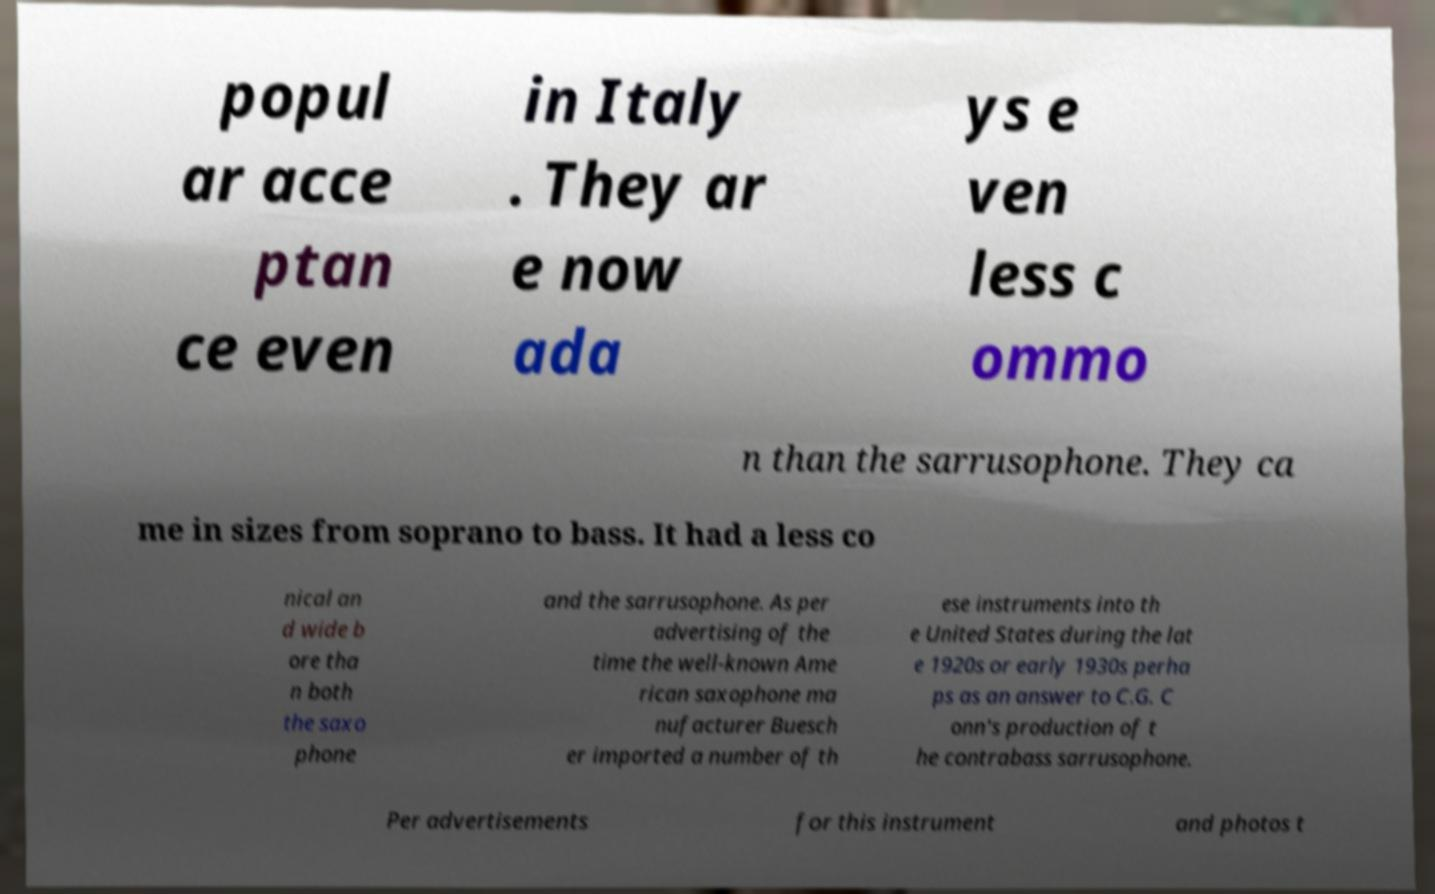I need the written content from this picture converted into text. Can you do that? popul ar acce ptan ce even in Italy . They ar e now ada ys e ven less c ommo n than the sarrusophone. They ca me in sizes from soprano to bass. It had a less co nical an d wide b ore tha n both the saxo phone and the sarrusophone. As per advertising of the time the well-known Ame rican saxophone ma nufacturer Buesch er imported a number of th ese instruments into th e United States during the lat e 1920s or early 1930s perha ps as an answer to C.G. C onn's production of t he contrabass sarrusophone. Per advertisements for this instrument and photos t 